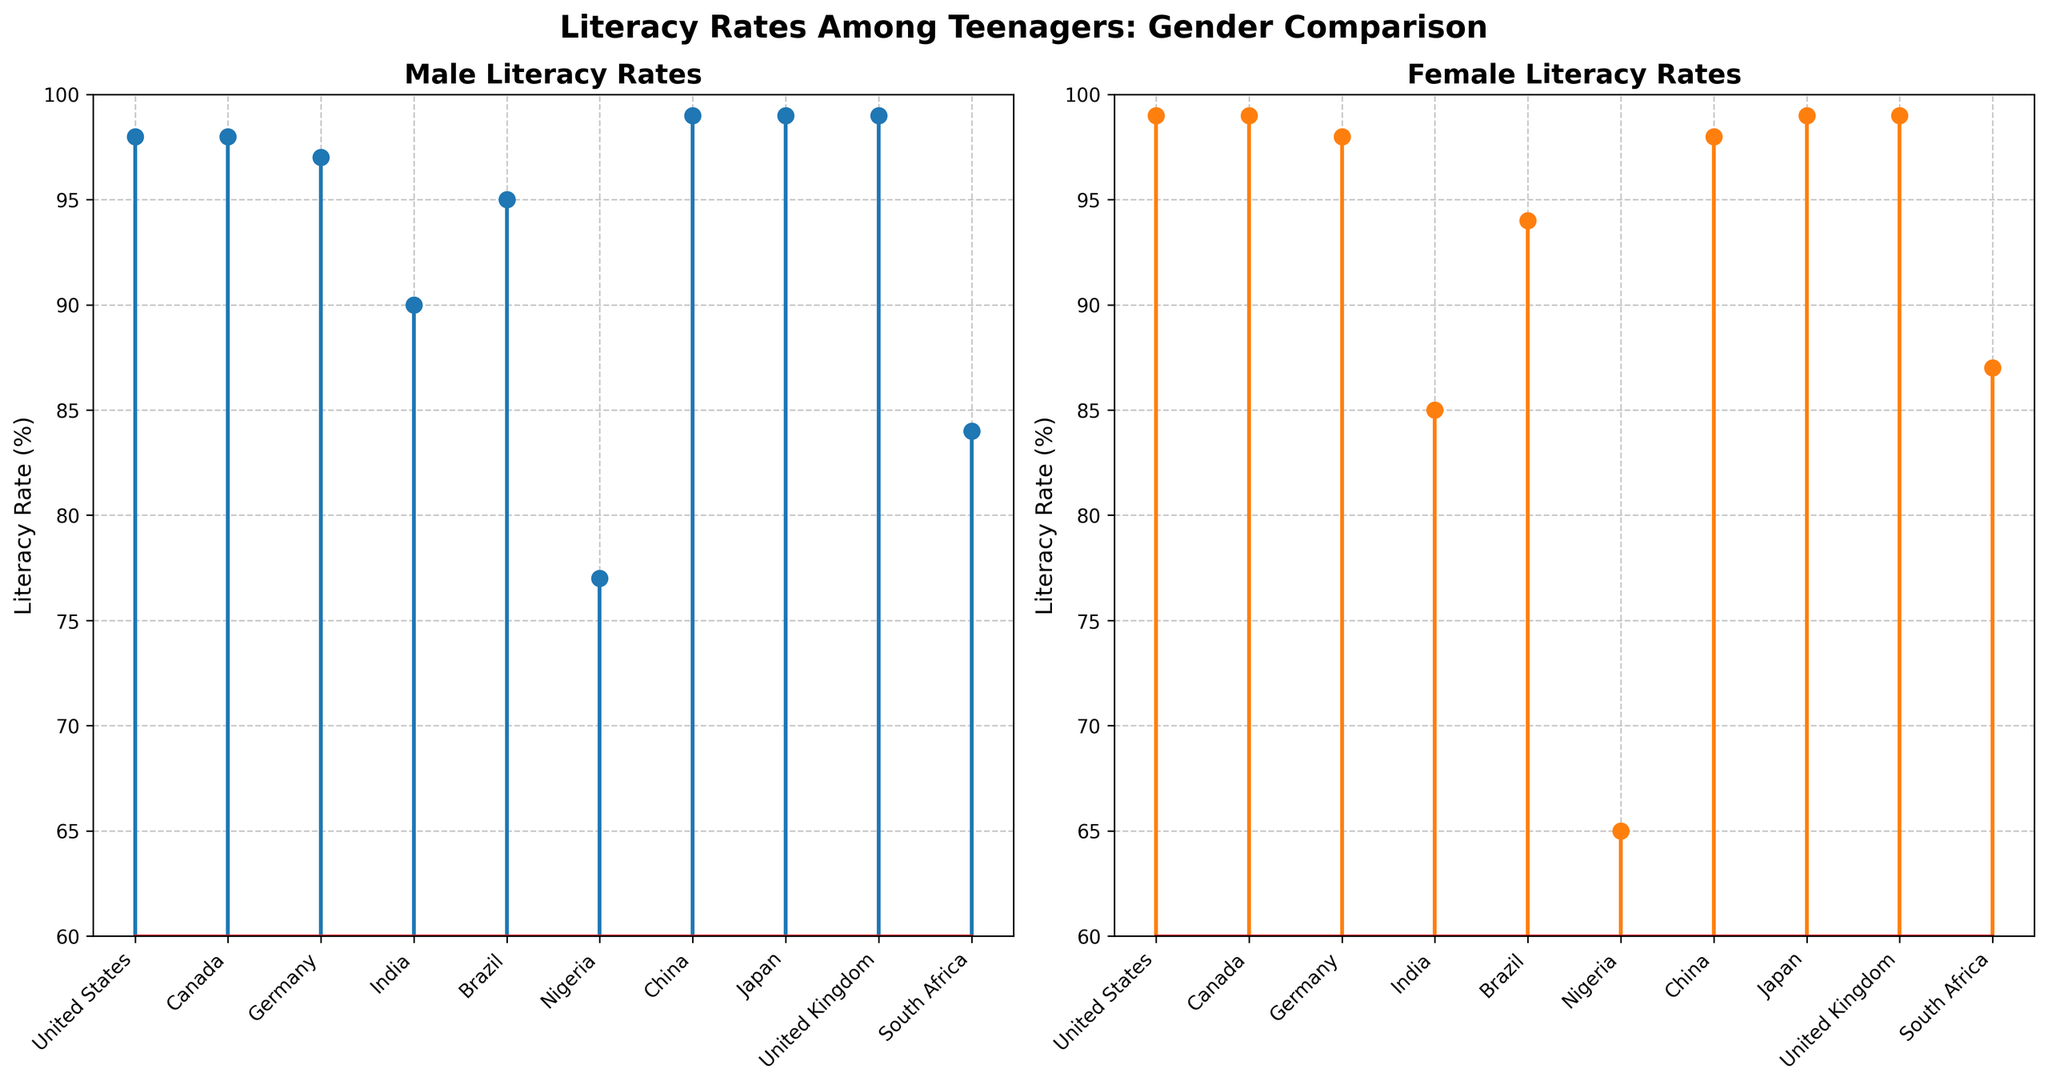Which country has the highest male literacy rate? According to the Male Literacy Rates plot on the left, several countries, including the United States, Canada, China, Japan, and the United Kingdom, have a male literacy rate of 99%, which is the highest among the listed countries.
Answer: United States, Canada, China, Japan, United Kingdom Which country has the lowest female literacy rate? According to the Female Literacy Rates plot on the right, Nigeria has the lowest female literacy rate at 65%.
Answer: Nigeria What is the difference between male and female literacy rates in India? In the Male Literacy Rates plot, India's literacy rate is 90%, and in the Female Literacy Rates plot, it is 85%. The difference is 90 - 85 = 5%.
Answer: 5% What is the average literacy rate for females across all countries? Sum the female literacy rates and divide by the number of countries. The sum is 99 + 99 + 98 + 85 + 94 + 65 + 98 + 99 + 99 + 87 = 923. There are 10 countries, so the average is 923/10 = 92.3%.
Answer: 92.3% Which gender has a higher literacy rate in South Africa? Comparing South Africa's rates in both plots, the male literacy rate is 84%, and the female literacy rate is 87%. Thus, females have a higher literacy rate.
Answer: Female What is the median male literacy rate? Listing male rates: 77, 84, 90, 95, 97, 98, 98, 99, 99, 99. The median is the middle value. With 10 values, the median is the average of the 5th and 6th: (97 + 98)/2 = 97.5.
Answer: 97.5% Which country has equal literacy rates for both genders? Look for countries with identical rates in both plots. Japan and the United Kingdom both have rates of 99% for both genders.
Answer: Japan, United Kingdom 